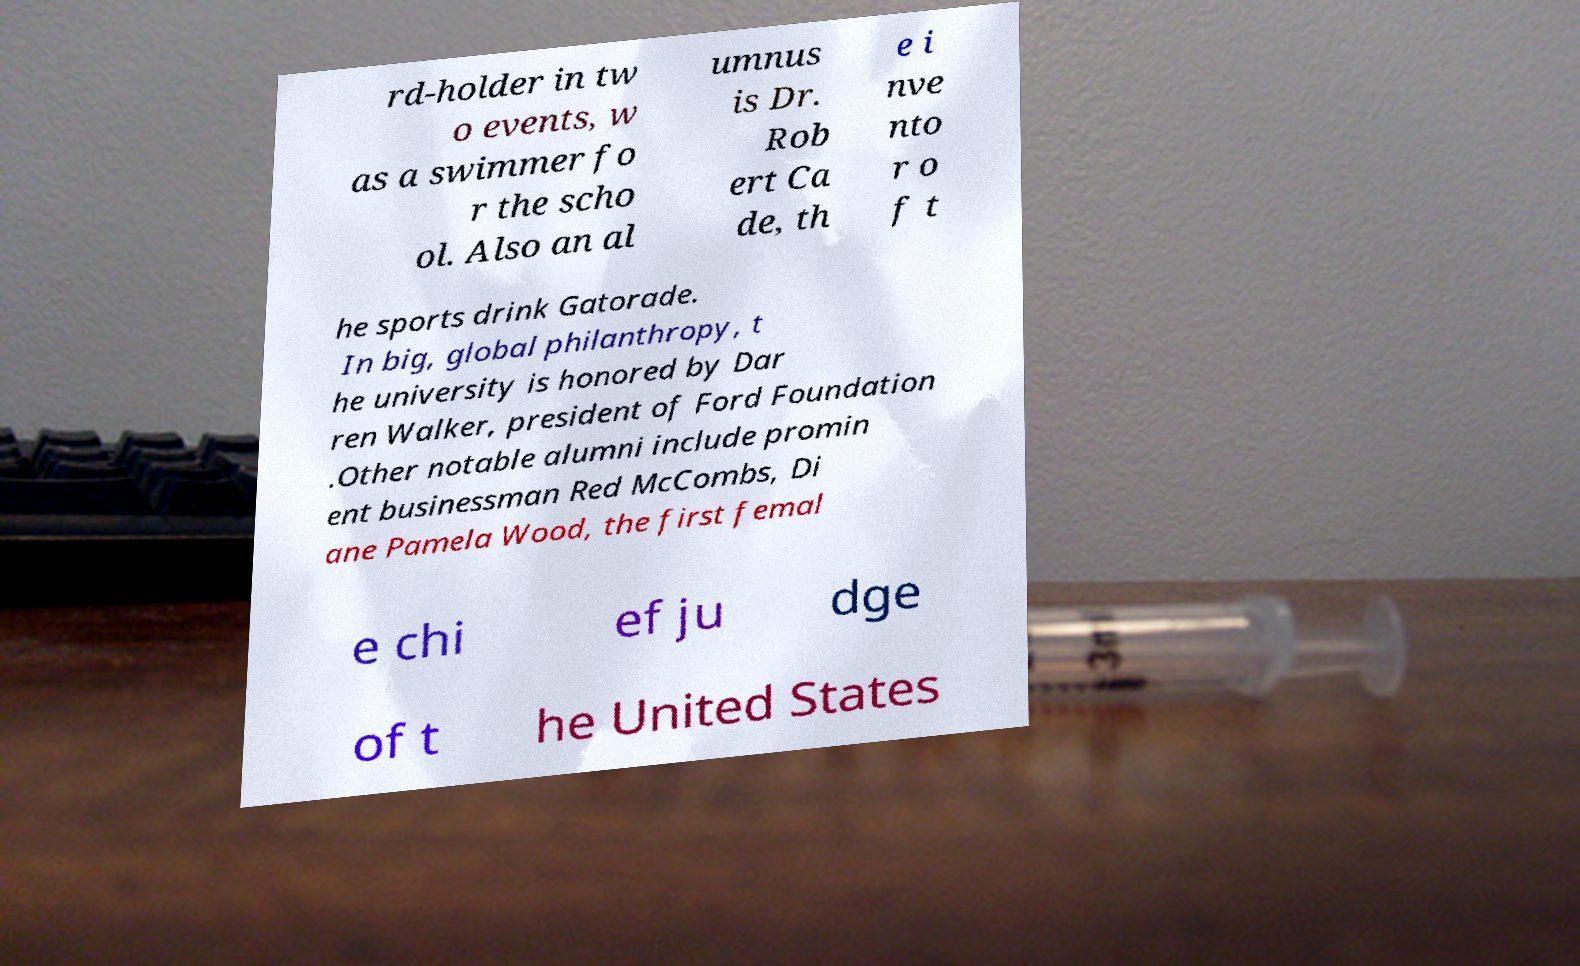There's text embedded in this image that I need extracted. Can you transcribe it verbatim? rd-holder in tw o events, w as a swimmer fo r the scho ol. Also an al umnus is Dr. Rob ert Ca de, th e i nve nto r o f t he sports drink Gatorade. In big, global philanthropy, t he university is honored by Dar ren Walker, president of Ford Foundation .Other notable alumni include promin ent businessman Red McCombs, Di ane Pamela Wood, the first femal e chi ef ju dge of t he United States 